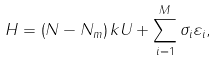<formula> <loc_0><loc_0><loc_500><loc_500>H = \left ( N - N _ { m } \right ) k U + \sum _ { i = 1 } ^ { M } \sigma _ { i } \varepsilon _ { i } ,</formula> 